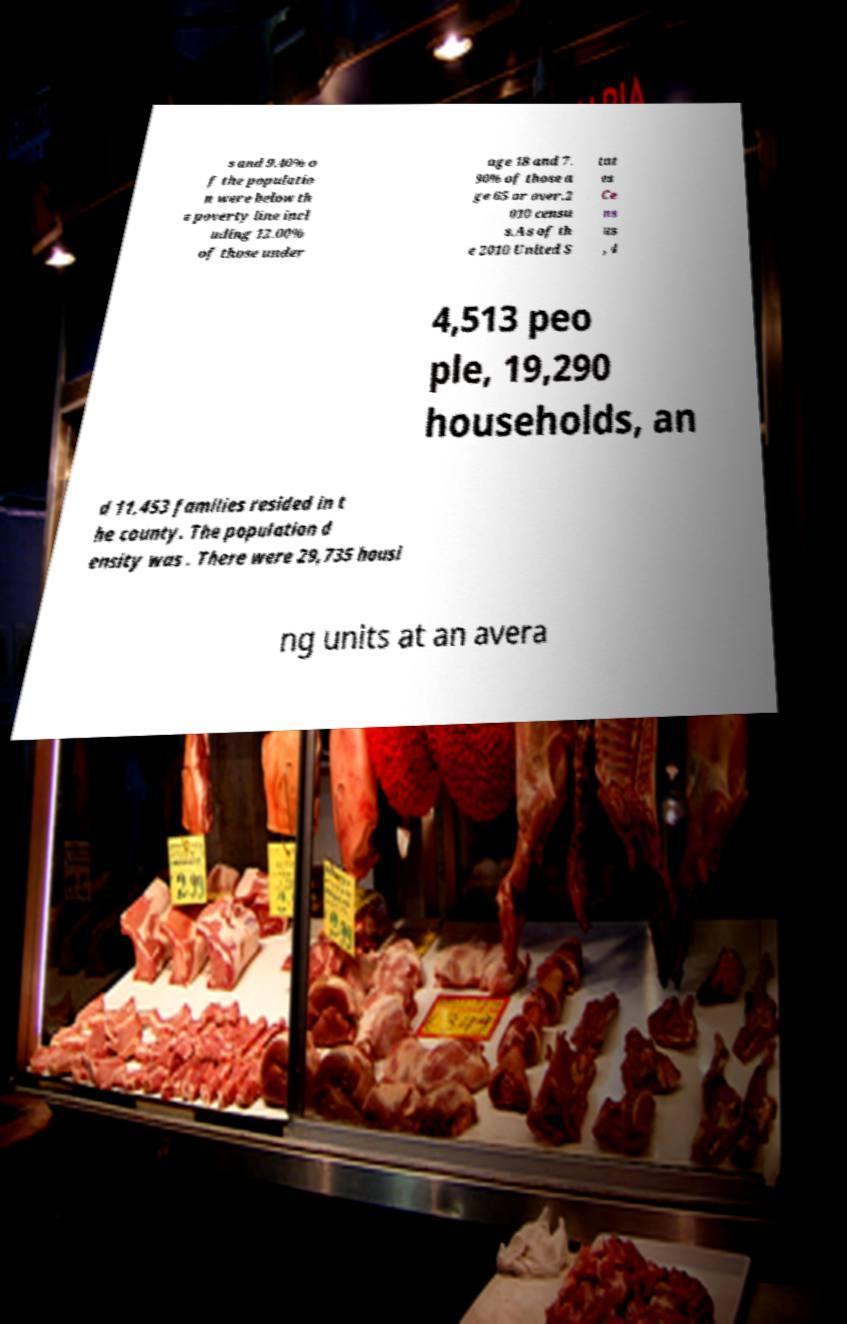Can you accurately transcribe the text from the provided image for me? s and 9.40% o f the populatio n were below th e poverty line incl uding 12.00% of those under age 18 and 7. 90% of those a ge 65 or over.2 010 censu s.As of th e 2010 United S tat es Ce ns us , 4 4,513 peo ple, 19,290 households, an d 11,453 families resided in t he county. The population d ensity was . There were 29,735 housi ng units at an avera 